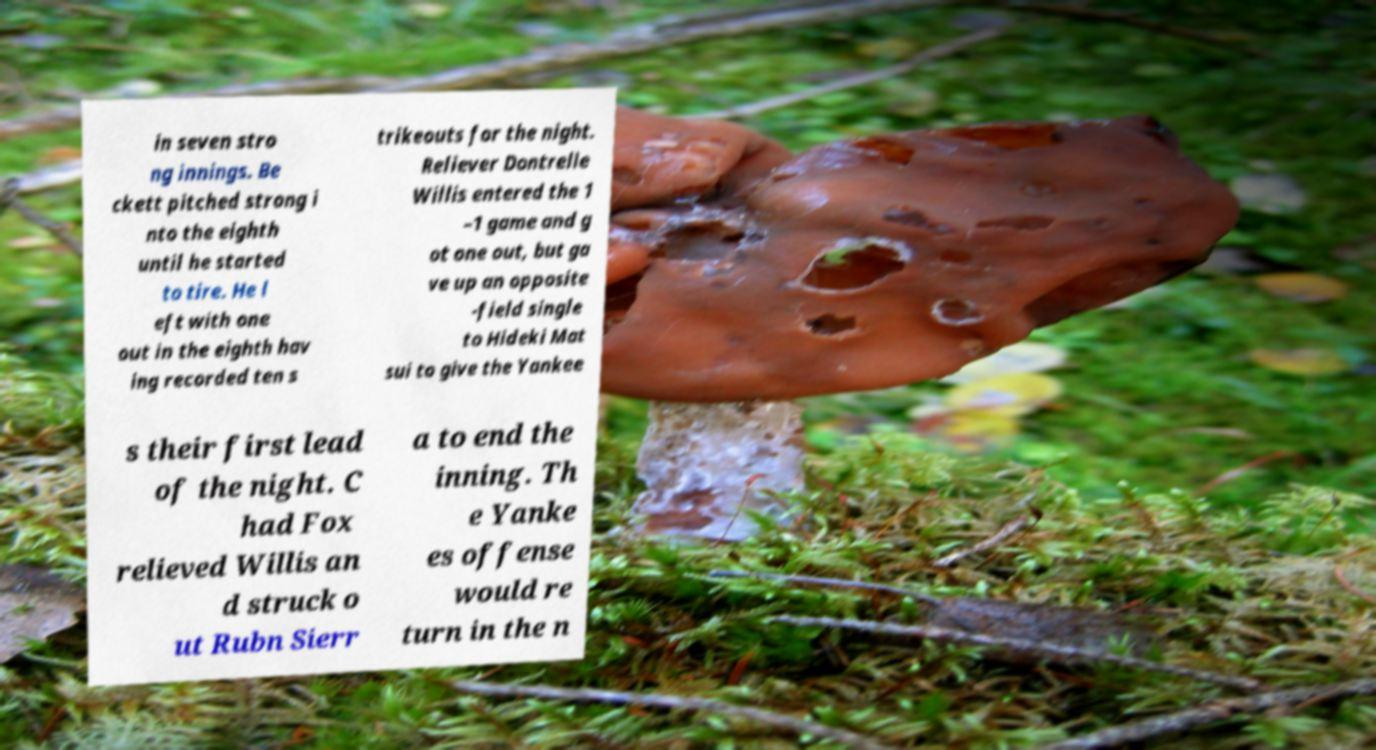Please identify and transcribe the text found in this image. in seven stro ng innings. Be ckett pitched strong i nto the eighth until he started to tire. He l eft with one out in the eighth hav ing recorded ten s trikeouts for the night. Reliever Dontrelle Willis entered the 1 –1 game and g ot one out, but ga ve up an opposite -field single to Hideki Mat sui to give the Yankee s their first lead of the night. C had Fox relieved Willis an d struck o ut Rubn Sierr a to end the inning. Th e Yanke es offense would re turn in the n 